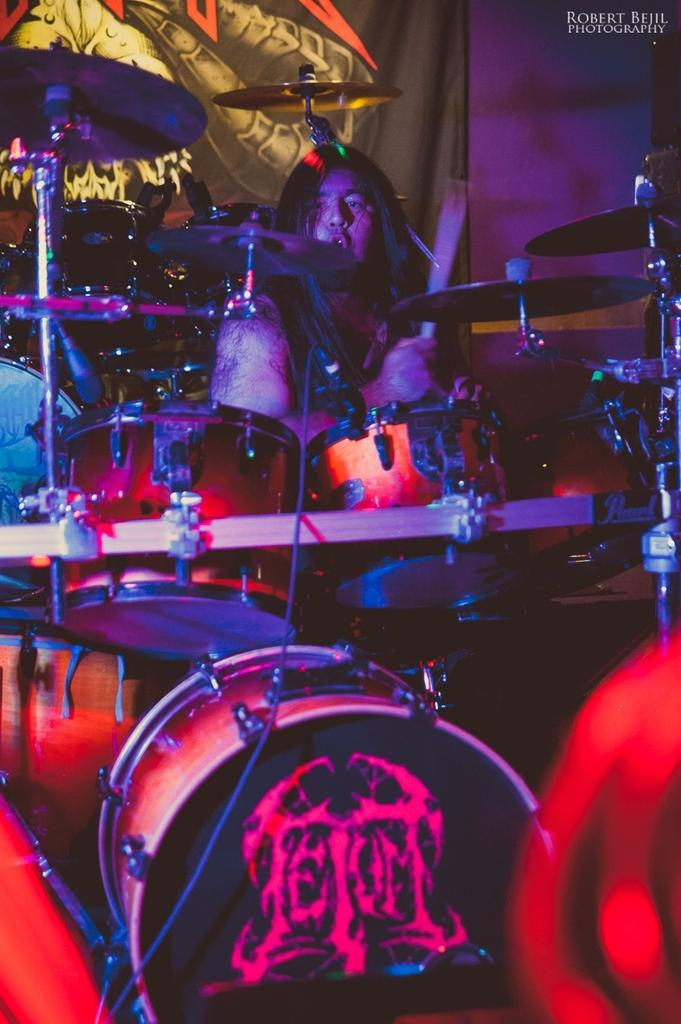What is the main subject in the middle of the image? There is a band in the middle of the image. What is the person at the top of the image holding? The person at the top of the image is holding a stick. What can be seen in the background of the image? There is a curtain in the background of the image. How many beds are visible in the image? There are no beds visible in the image. What type of frog can be seen playing a musical instrument in the image? There is no frog present in the image, let alone one playing a musical instrument. 